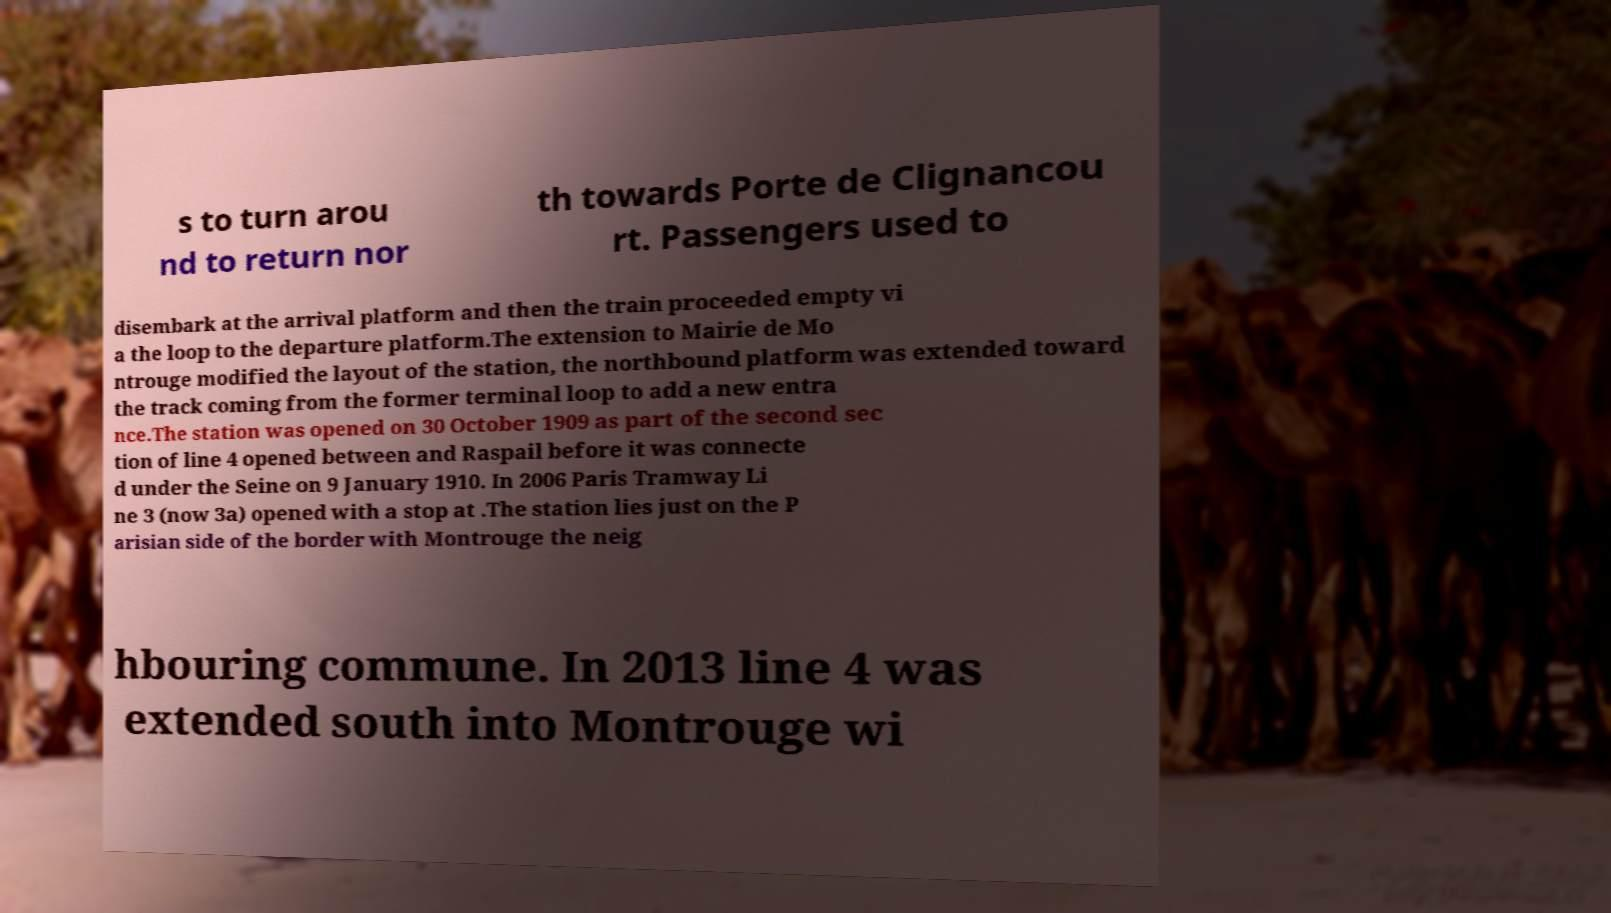What messages or text are displayed in this image? I need them in a readable, typed format. s to turn arou nd to return nor th towards Porte de Clignancou rt. Passengers used to disembark at the arrival platform and then the train proceeded empty vi a the loop to the departure platform.The extension to Mairie de Mo ntrouge modified the layout of the station, the northbound platform was extended toward the track coming from the former terminal loop to add a new entra nce.The station was opened on 30 October 1909 as part of the second sec tion of line 4 opened between and Raspail before it was connecte d under the Seine on 9 January 1910. In 2006 Paris Tramway Li ne 3 (now 3a) opened with a stop at .The station lies just on the P arisian side of the border with Montrouge the neig hbouring commune. In 2013 line 4 was extended south into Montrouge wi 